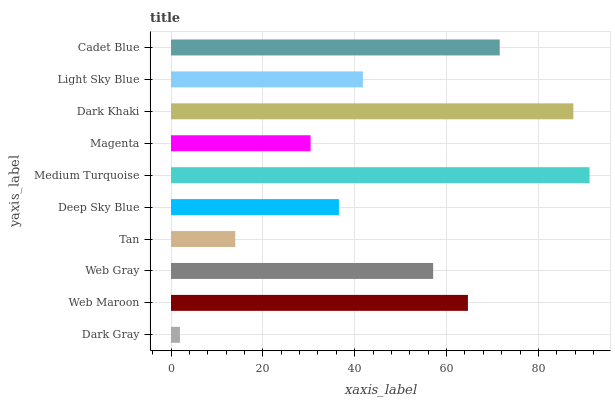Is Dark Gray the minimum?
Answer yes or no. Yes. Is Medium Turquoise the maximum?
Answer yes or no. Yes. Is Web Maroon the minimum?
Answer yes or no. No. Is Web Maroon the maximum?
Answer yes or no. No. Is Web Maroon greater than Dark Gray?
Answer yes or no. Yes. Is Dark Gray less than Web Maroon?
Answer yes or no. Yes. Is Dark Gray greater than Web Maroon?
Answer yes or no. No. Is Web Maroon less than Dark Gray?
Answer yes or no. No. Is Web Gray the high median?
Answer yes or no. Yes. Is Light Sky Blue the low median?
Answer yes or no. Yes. Is Medium Turquoise the high median?
Answer yes or no. No. Is Deep Sky Blue the low median?
Answer yes or no. No. 